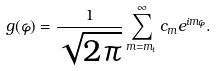<formula> <loc_0><loc_0><loc_500><loc_500>g ( \varphi ) = \frac { 1 } { \sqrt { 2 \pi } } \sum _ { m = m _ { t } } ^ { \infty } c _ { m } e ^ { i m \varphi } .</formula> 